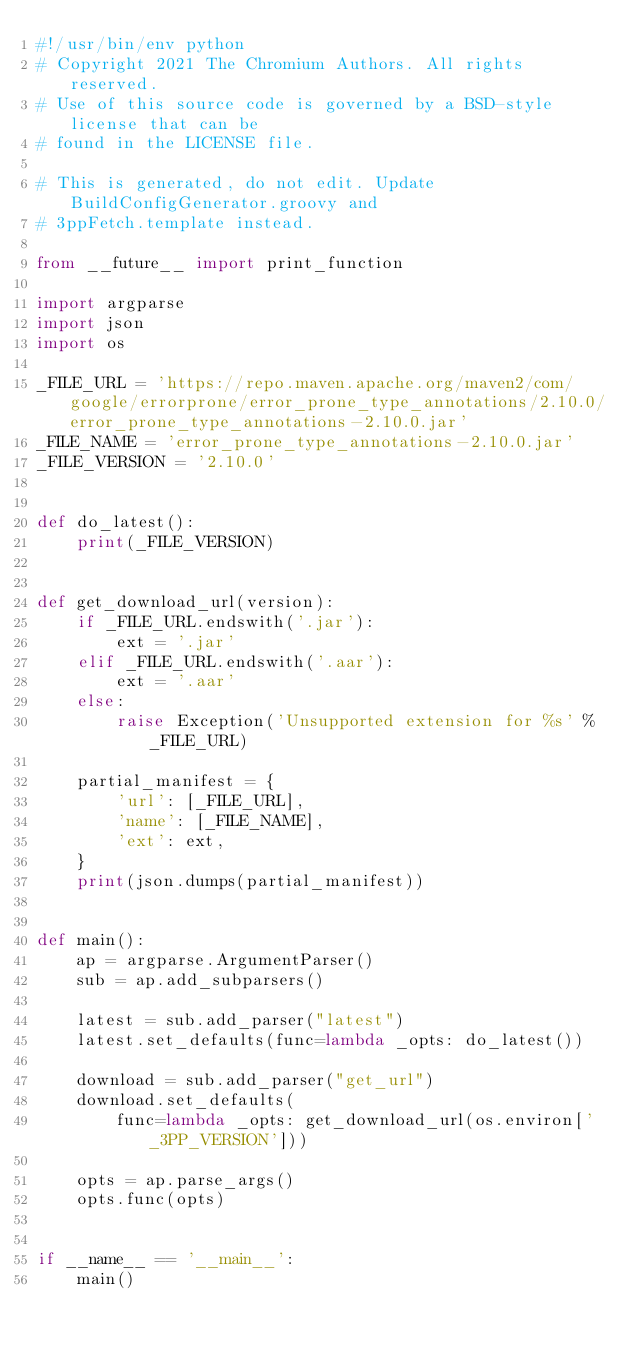Convert code to text. <code><loc_0><loc_0><loc_500><loc_500><_Python_>#!/usr/bin/env python
# Copyright 2021 The Chromium Authors. All rights reserved.
# Use of this source code is governed by a BSD-style license that can be
# found in the LICENSE file.

# This is generated, do not edit. Update BuildConfigGenerator.groovy and
# 3ppFetch.template instead.

from __future__ import print_function

import argparse
import json
import os

_FILE_URL = 'https://repo.maven.apache.org/maven2/com/google/errorprone/error_prone_type_annotations/2.10.0/error_prone_type_annotations-2.10.0.jar'
_FILE_NAME = 'error_prone_type_annotations-2.10.0.jar'
_FILE_VERSION = '2.10.0'


def do_latest():
    print(_FILE_VERSION)


def get_download_url(version):
    if _FILE_URL.endswith('.jar'):
        ext = '.jar'
    elif _FILE_URL.endswith('.aar'):
        ext = '.aar'
    else:
        raise Exception('Unsupported extension for %s' % _FILE_URL)

    partial_manifest = {
        'url': [_FILE_URL],
        'name': [_FILE_NAME],
        'ext': ext,
    }
    print(json.dumps(partial_manifest))


def main():
    ap = argparse.ArgumentParser()
    sub = ap.add_subparsers()

    latest = sub.add_parser("latest")
    latest.set_defaults(func=lambda _opts: do_latest())

    download = sub.add_parser("get_url")
    download.set_defaults(
        func=lambda _opts: get_download_url(os.environ['_3PP_VERSION']))

    opts = ap.parse_args()
    opts.func(opts)


if __name__ == '__main__':
    main()
</code> 